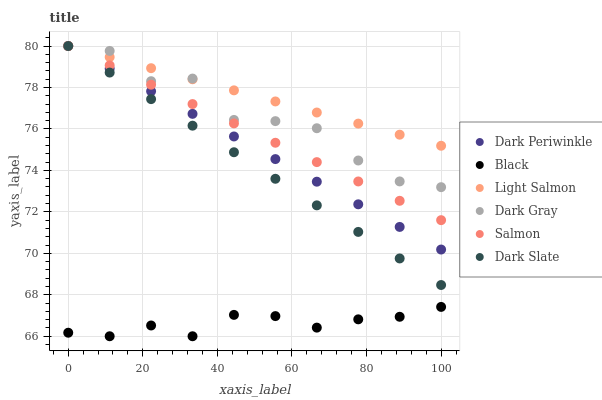Does Black have the minimum area under the curve?
Answer yes or no. Yes. Does Light Salmon have the maximum area under the curve?
Answer yes or no. Yes. Does Salmon have the minimum area under the curve?
Answer yes or no. No. Does Salmon have the maximum area under the curve?
Answer yes or no. No. Is Dark Slate the smoothest?
Answer yes or no. Yes. Is Dark Gray the roughest?
Answer yes or no. Yes. Is Salmon the smoothest?
Answer yes or no. No. Is Salmon the roughest?
Answer yes or no. No. Does Black have the lowest value?
Answer yes or no. Yes. Does Salmon have the lowest value?
Answer yes or no. No. Does Dark Periwinkle have the highest value?
Answer yes or no. Yes. Does Black have the highest value?
Answer yes or no. No. Is Black less than Dark Gray?
Answer yes or no. Yes. Is Salmon greater than Black?
Answer yes or no. Yes. Does Dark Periwinkle intersect Dark Slate?
Answer yes or no. Yes. Is Dark Periwinkle less than Dark Slate?
Answer yes or no. No. Is Dark Periwinkle greater than Dark Slate?
Answer yes or no. No. Does Black intersect Dark Gray?
Answer yes or no. No. 